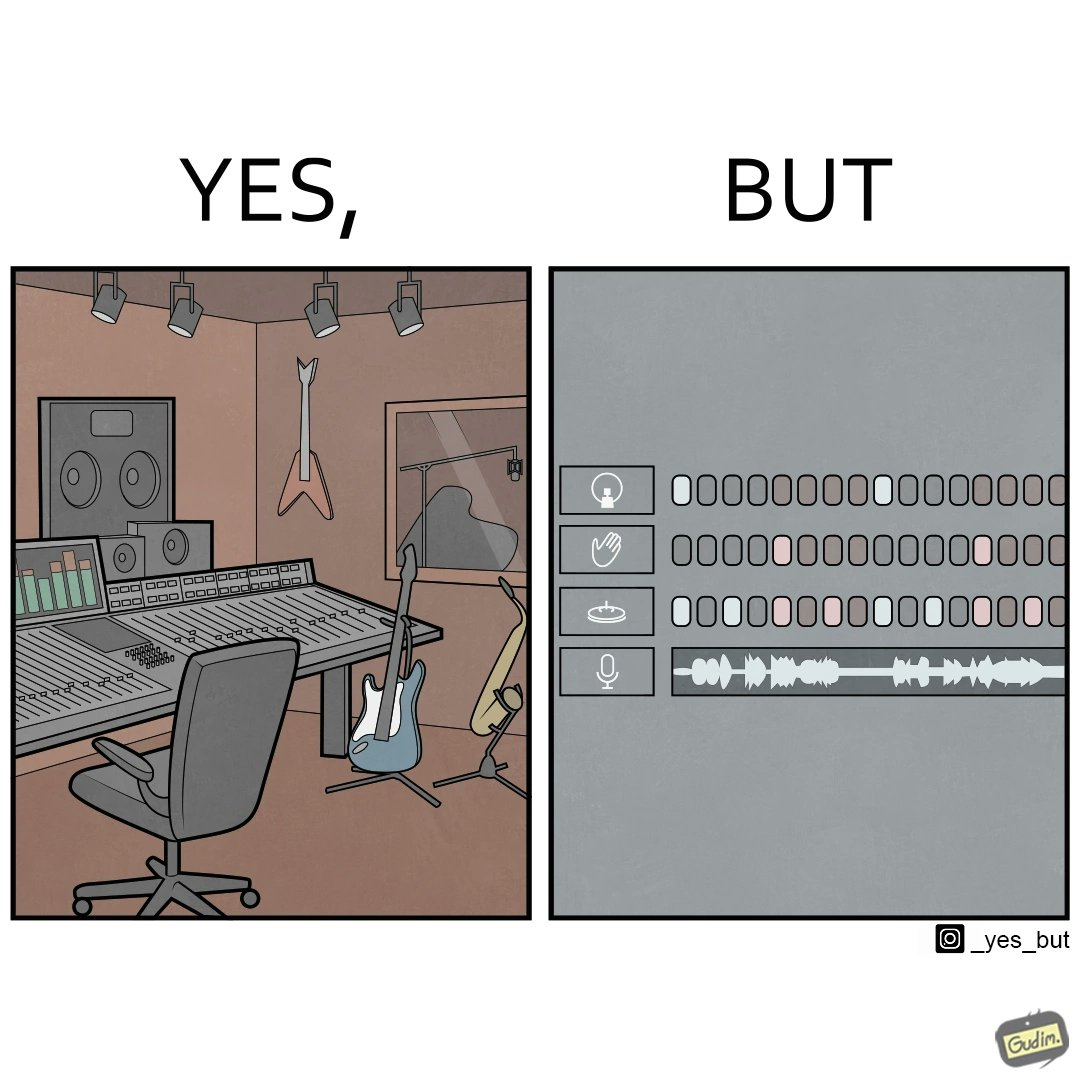Describe what you see in this image. The image overall is funny because even though people have great music studios and instruments to create and record music, they use electronic replacements of the musical instruments to achieve the task. 